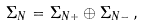<formula> <loc_0><loc_0><loc_500><loc_500>\Sigma _ { N } = \Sigma _ { N + } \oplus \Sigma _ { N - } \, ,</formula> 